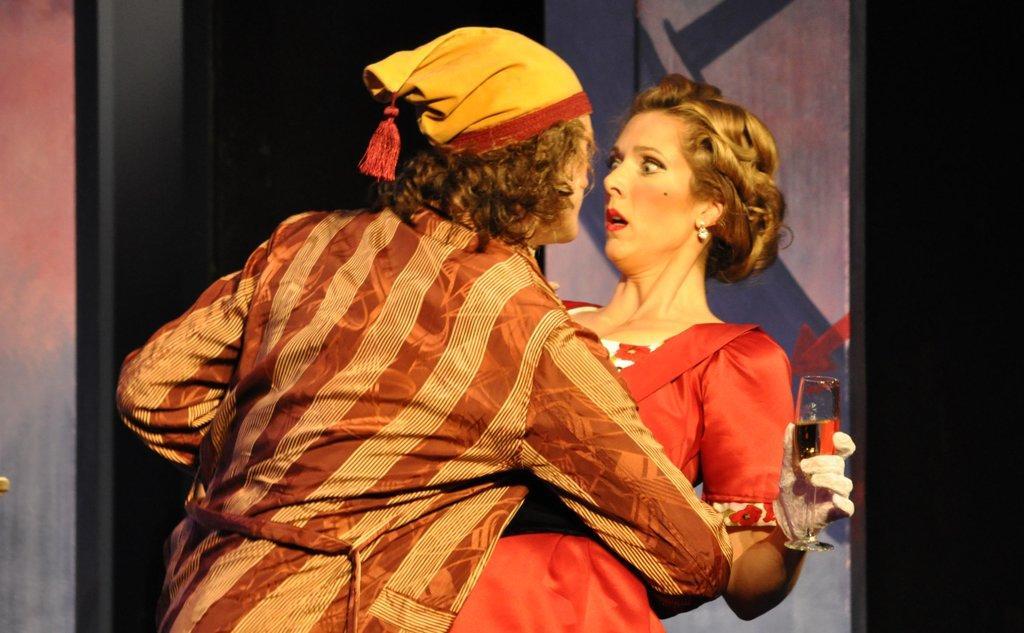Describe this image in one or two sentences. In this image we can see a man and a lady. There is a glass in her hand. In the background there is a board. 